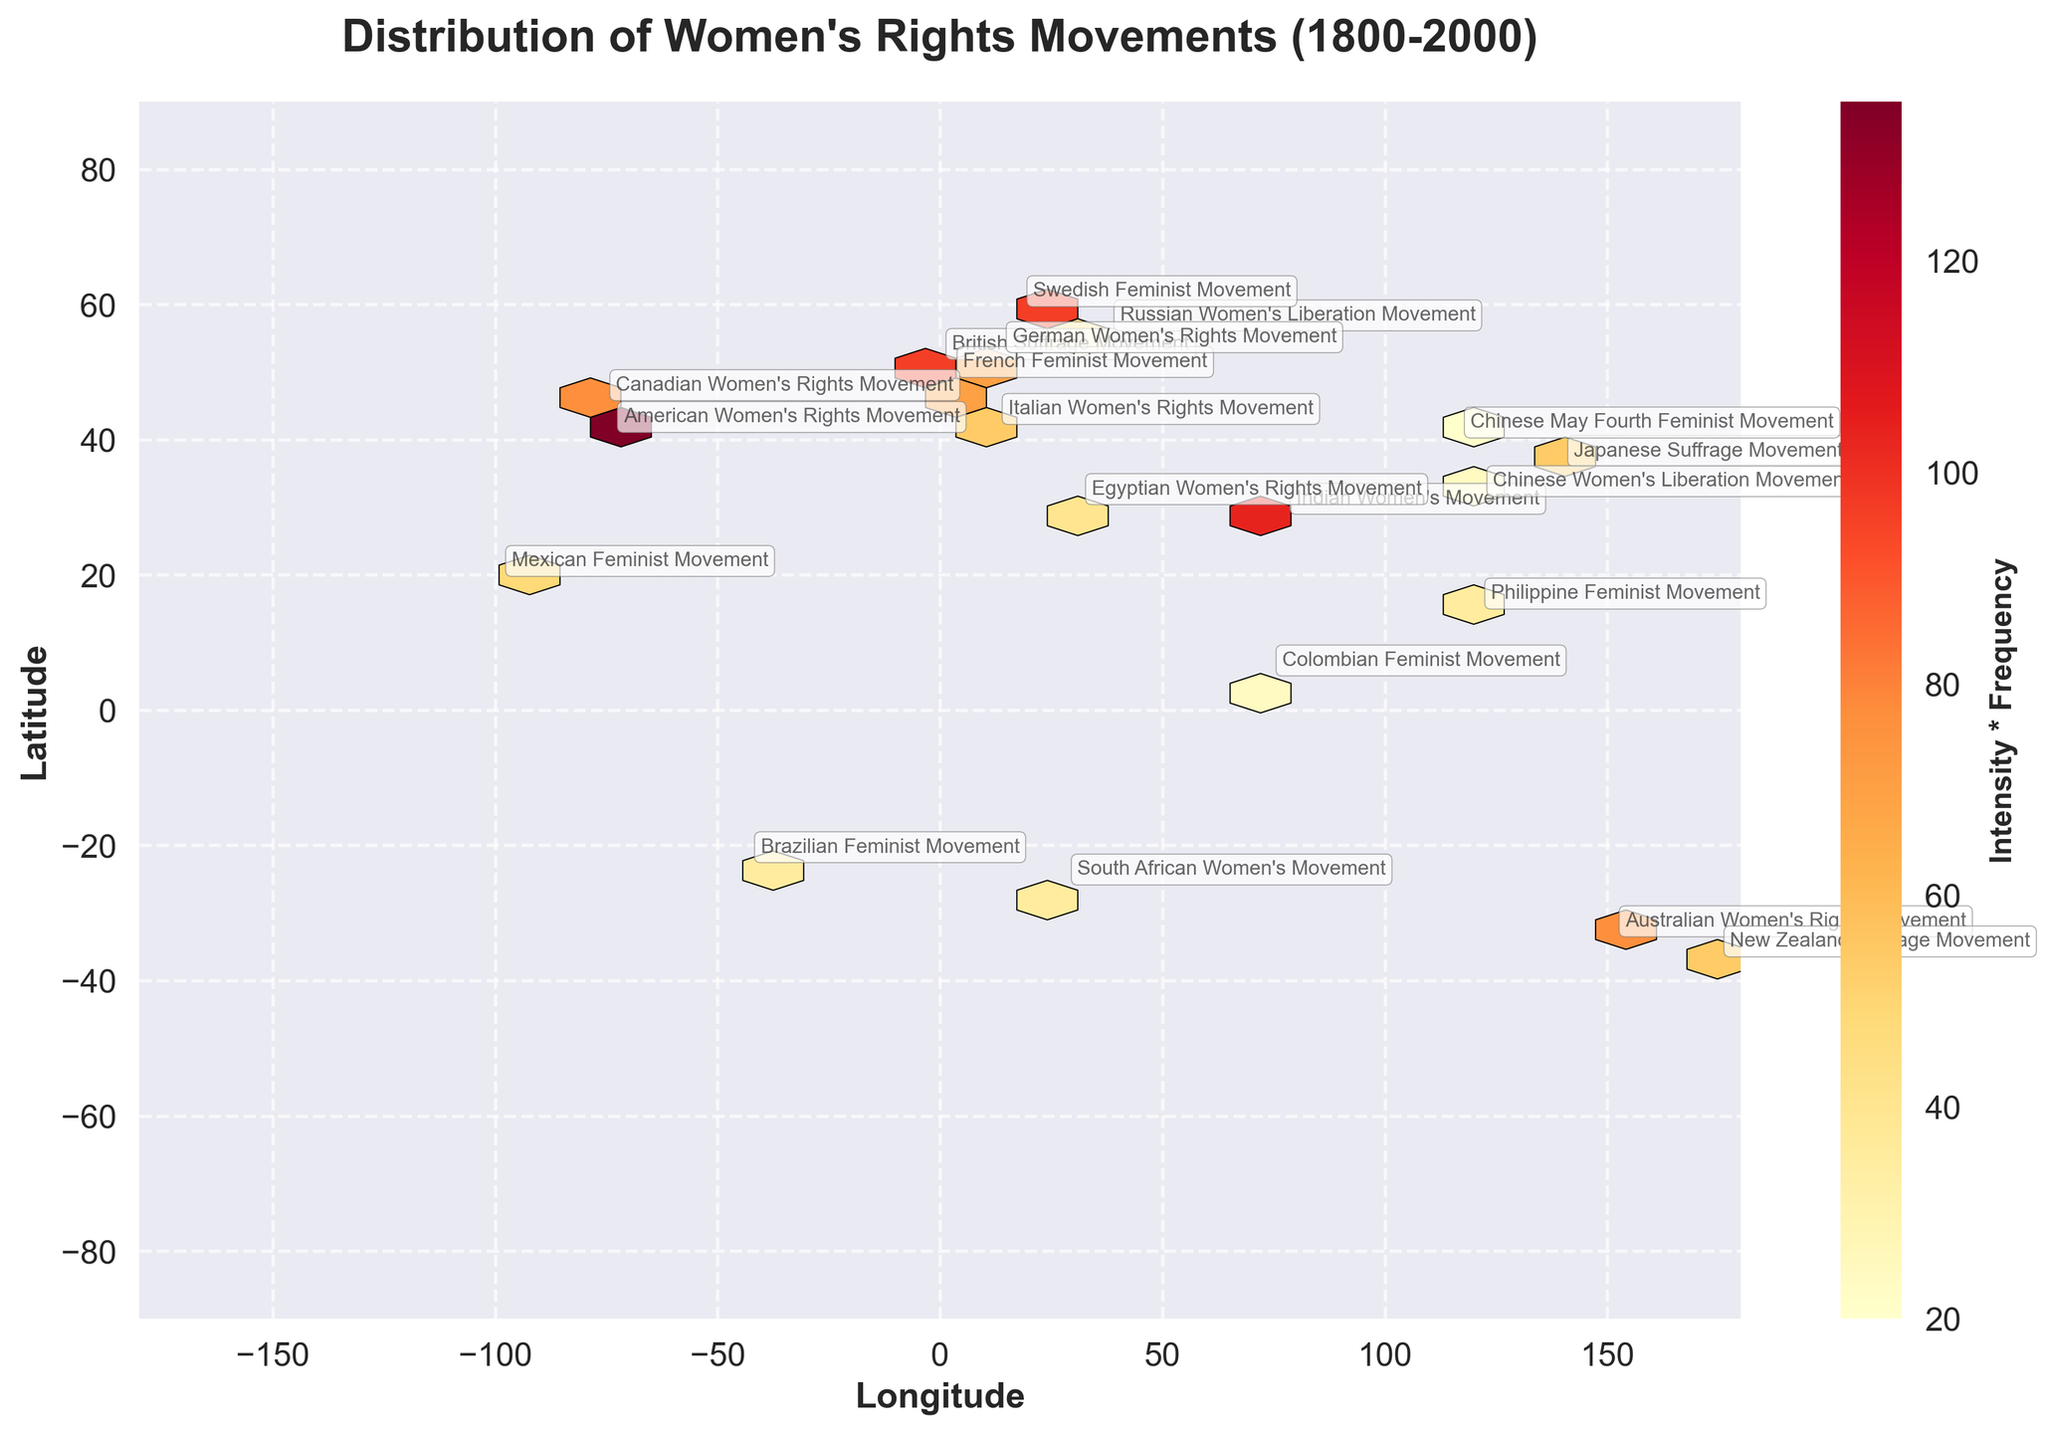What's the title of the plot? The title of the plot is displayed at the top and is named "Distribution of Women's Rights Movements (1800-2000)"
Answer: Distribution of Women's Rights Movements (1800-2000) Which movement has the highest value for 'Intensity * Frequency'? By examining the hexbin colors and annotations, the American Women's Rights Movement shows the highest intensity (9) and frequency (15), leading to the highest product of intensity and frequency.
Answer: American Women's Rights Movement How many movements have a location within Europe? The locations in Europe include: London (British Suffrage Movement), Paris (French Feminist Movement), Berlin (German Women's Rights Movement), Rome (Italian Women's Rights Movement), and Stockholm (Swedish Feminist Movement). Count these to find the number of movements.
Answer: 5 What are the axes labels on the plot? The x-axis and y-axis labels are displayed as "Longitude" and "Latitude" respectively. Simply refer to the labels next to each axis for this information.
Answer: Longitude and Latitude Which two movements have an intensity of 7 and are located in different continents? From the annotations and numerical details, the "French Feminist Movement" in Paris and the "Australian Women's Rights Movement" in Sydney both have an intensity of 7 and are located in Europe and Australia respectively.
Answer: French Feminist Movement and Australian Women's Rights Movement Compare the intensity and frequency values of the Swedish Feminist Movement and the Japanese Suffrage Movement. Which one has the higher product of Intensity and Frequency? The Swedish Feminist Movement has an Intensity of 8 and a Frequency of 12, yielding a product of 96. The Japanese Suffrage Movement has an Intensity of 6 and a Frequency of 9, yielding a product of 54. The Swedish Feminist Movement has a higher product.
Answer: Swedish Feminist Movement What is the range of Longitude values covered in the plot? The plot's x-axis (Longitude) ranges from -180 to 180, as indicated by the axis limits and scale marks.
Answer: -180 to 180 Calculate the average Intensity for the movements located at a Latitude between 30 and 40 degrees. Only the Indian Women's Movement (8) and Chinese May Fourth Feminist Movement (4) fall within this Latitude range. The average intensity is calculated as (8 + 4) / 2 = 6.
Answer: 6 What does the color intensity in the hexbin plot represent? According to the color bar and the plot's descriptive details, the color intensity represents the product of 'Intensity' and 'Frequency' for the movements. The brighter the color, the higher the product value.
Answer: Product of Intensity and Frequency 